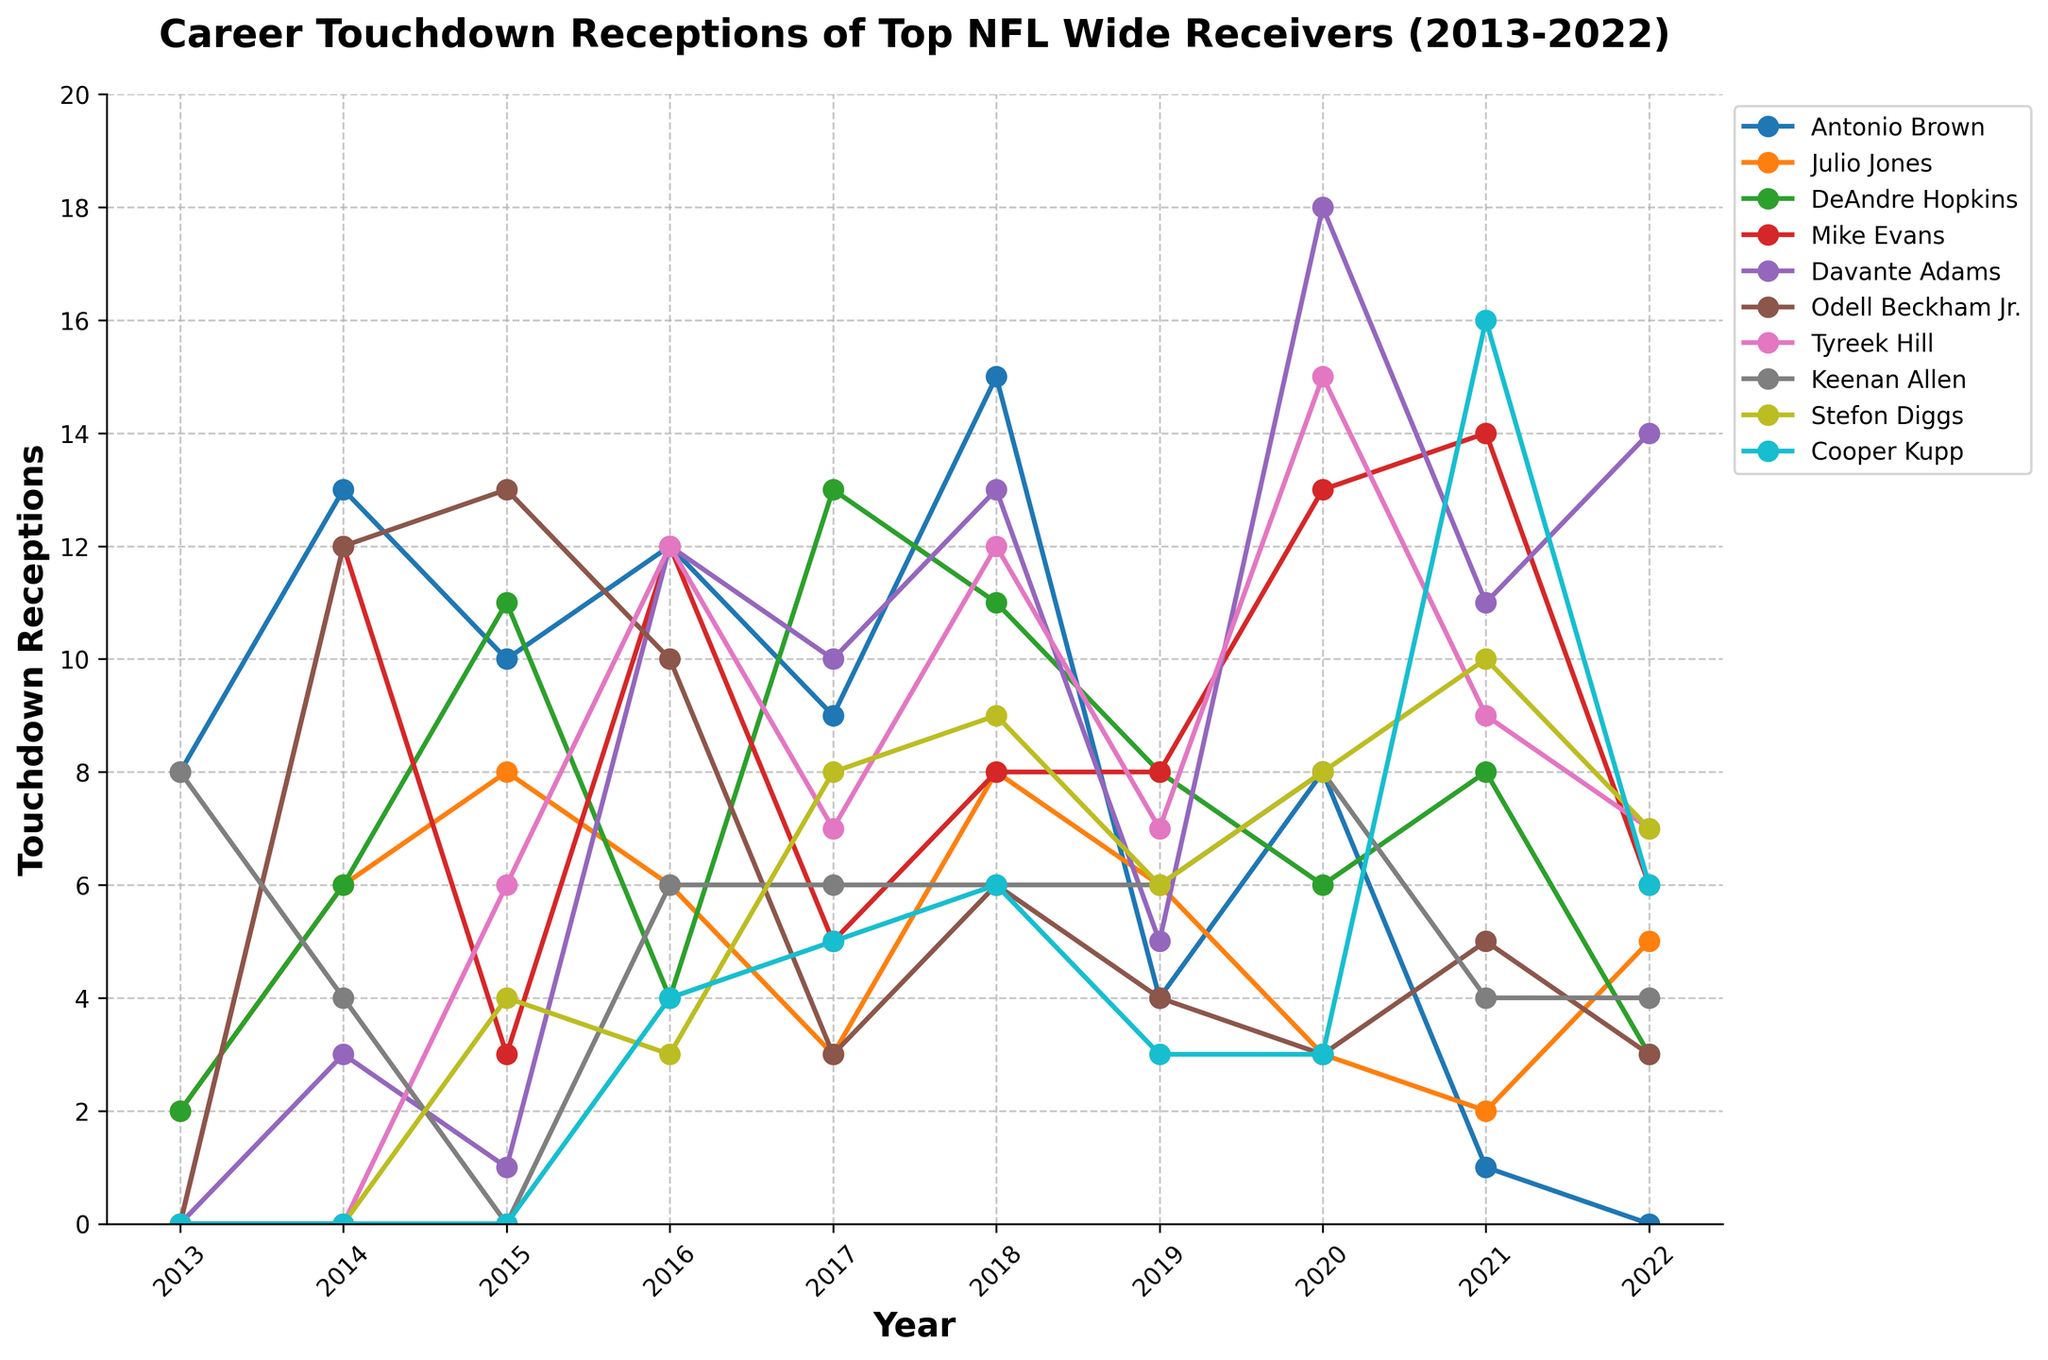who had the highest number of touchdown receptions in 2018? To find this, look at the 2018 column and identify the player with the highest touchdown receptions.
Answer: Antonio Brown Which player had the most consistent performance (least fluctuation) throughout the 10 years? Determine the player whose touchdown receptions varied the least over the years. Consider the players whose lines are comparatively the smoothest without sharp increases or decreases.
Answer: Keenan Allen What is the total number of touchdown receptions for Davante Adams from 2013 to 2022? Sum the touchdown receptions of Davante Adams for each year: 0+3+1+12+10+13+5+18+11+14.
Answer: 87 Who had more touchdown receptions in 2022, Tyreek Hill or Mike Evans? Compare the touchdown receptions of Tyreek Hill and Mike Evans in the year 2022 column.
Answer: Mike Evans What was the average number of touchdown receptions per year for Julio Jones? Calculate the sum of Julio Jones' touchdown receptions across the years and divide by 10 (number of years): (2+6+8+6+3+8+6+3+2+5)/10.
Answer: 4.9 Out of the listed players, who had the highest single year touchdown reception and in which year? Identify the highest value in the entire chart and then find out which player and year it corresponds to.
Answer: Davante Adams, 2020 Compare Antonio Brown's touchdown receptions in 2014 and 2018. How many more touchdowns did he have in 2018? Subtract Antonio Brown's 2014 touchdowns from his 2018 touchdowns: 15 - 13.
Answer: 2 In how many years did Cooper Kupp have zero touchdown receptions? Count the years where Cooper Kupp's touchdown receptions were zero.
Answer: 3 Which player had the lowest total touchdown receptions over the decade? Sum up the touchdown receptions for each player over the years and identify the smallest sum.
Answer: Cooper Kupp Did any player have back-to-back years with the same number of touchdown receptions? If so, who? Look for instances where a player's touchdown receptions are the same in two consecutive years.
Answer: Stefon Diggs (2019 and 2020 with 6 touchdowns) 